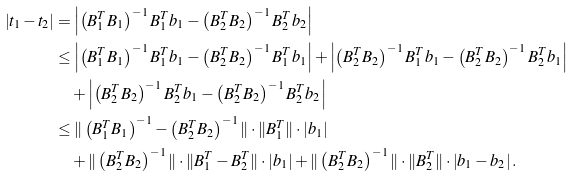<formula> <loc_0><loc_0><loc_500><loc_500>\left | { t } _ { 1 } - { t } _ { 2 } \right | & = \left | \left ( B ^ { T } _ { 1 } B _ { 1 } \right ) ^ { - 1 } B _ { 1 } ^ { T } { b } _ { 1 } - \left ( B ^ { T } _ { 2 } B _ { 2 } \right ) ^ { - 1 } B _ { 2 } ^ { T } { b } _ { 2 } \right | \\ & \leq \left | \left ( B ^ { T } _ { 1 } B _ { 1 } \right ) ^ { - 1 } B _ { 1 } ^ { T } { b } _ { 1 } - \left ( B ^ { T } _ { 2 } B _ { 2 } \right ) ^ { - 1 } B _ { 1 } ^ { T } { b } _ { 1 } \right | + \left | \left ( B ^ { T } _ { 2 } B _ { 2 } \right ) ^ { - 1 } B _ { 1 } ^ { T } { b } _ { 1 } - \left ( B ^ { T } _ { 2 } B _ { 2 } \right ) ^ { - 1 } B _ { 2 } ^ { T } { b } _ { 1 } \right | \\ & \quad + \left | \left ( B ^ { T } _ { 2 } B _ { 2 } \right ) ^ { - 1 } B _ { 2 } ^ { T } { b } _ { 1 } - \left ( B ^ { T } _ { 2 } B _ { 2 } \right ) ^ { - 1 } B _ { 2 } ^ { T } { b } _ { 2 } \right | \\ & \leq \| \left ( B ^ { T } _ { 1 } B _ { 1 } \right ) ^ { - 1 } - \left ( B ^ { T } _ { 2 } B _ { 2 } \right ) ^ { - 1 } \| \cdot \| B _ { 1 } ^ { T } \| \cdot \left | { b } _ { 1 } \right | \\ & \quad + \| \left ( B ^ { T } _ { 2 } B _ { 2 } \right ) ^ { - 1 } \| \cdot \| B ^ { T } _ { 1 } - B ^ { T } _ { 2 } \| \cdot \left | { b } _ { 1 } \right | + \| \left ( B ^ { T } _ { 2 } B _ { 2 } \right ) ^ { - 1 } \| \cdot \| B ^ { T } _ { 2 } \| \cdot \left | { b } _ { 1 } - { b } _ { 2 } \right | .</formula> 